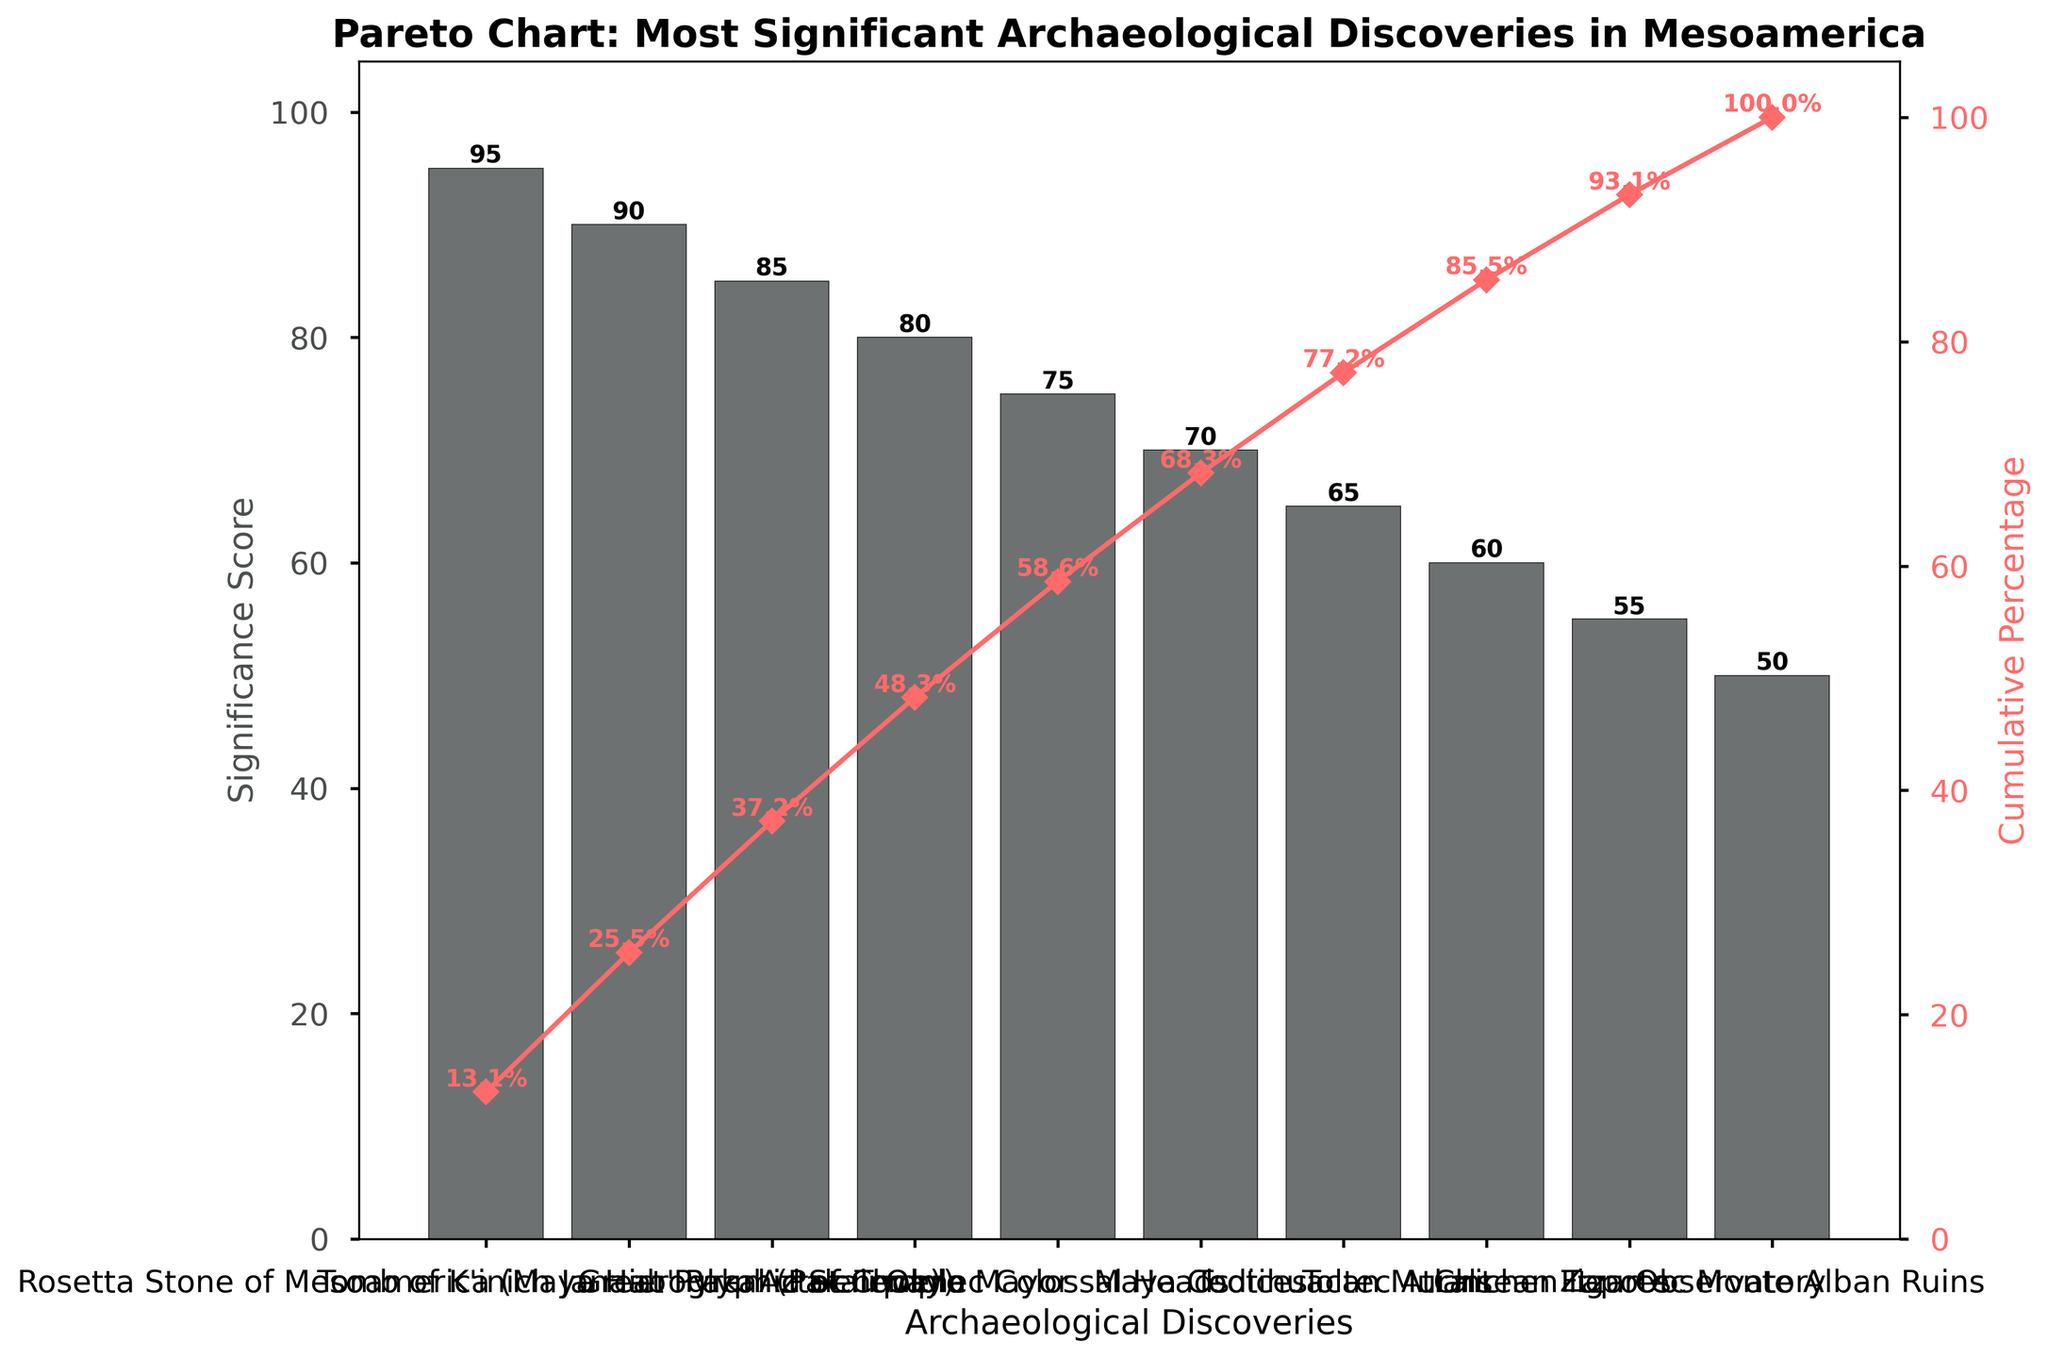How many discoveries are shown on the chart? By looking at the x-axis which lists all the discoveries, we can count the number there.
Answer: 10 Which discovery has the highest significance score? By observing the heights of the bars, the "Rosetta Stone of Mesoamerica (Maya Hieroglyphic Stairway)" is the tallest, indicating it has the highest significance score.
Answer: Rosetta Stone of Mesoamerica (Maya Hieroglyphic Stairway) What is the title of the chart? The title is located at the top of the chart.
Answer: Pareto Chart: Most Significant Archaeological Discoveries in Mesoamerica What does the red line represent? The red line corresponds to the right y-axis labeled "Cumulative Percentage". It shows the cumulative percentage of the significance scores.
Answer: Cumulative percentage What is the cumulative percentage after including the top 3 discoveries? Observe the red line and its respective values, which show cumulative percentage after each discovery. After the top 3 discoveries, the cumulative percentage is around 77% (95 + 90 + 85) / (Total Score) * 100.
Answer: 75.0% Which discovery contributes just above 50% to the cumulative percentage? Looking at the red line, find the point where the cumulative percentage just exceeds 50%. It happens right after the "Olmec Colossal Heads" which has a cumulative percentage of around 68%.
Answer: Olmec Colossal Heads What's the significance score of the third most significant discovery? By counting down to the third bar, "Great Pyramid of Cholula" has the third highest bar, with a significance score noted above the bar.
Answer: 85 What is the difference in significance scores between the Aztec Templo Mayor and Olmec Colossal Heads? Subtract the significance score of Olmec Colossal Heads (75) from that of Aztec Templo Mayor (80).
Answer: 5 Which discoveries collectively make up about 80% of the cumulative significance score? Following the red line cumulative percentage, we identify the first discoveries up until the value that is close to 80%. This includes "Rosetta Stone of Mesoamerica (Maya Hieroglyphic Stairway)," "Tomb of K'inich Janaab' Pakal (Palenque)," "Great Pyramid of Cholula," and "Aztec Templo Mayor."
Answer: The first four discoveries How many discoveries have a significance score greater than 70? Count the bars higher than the 70-mark on the left y-axis.
Answer: 5 